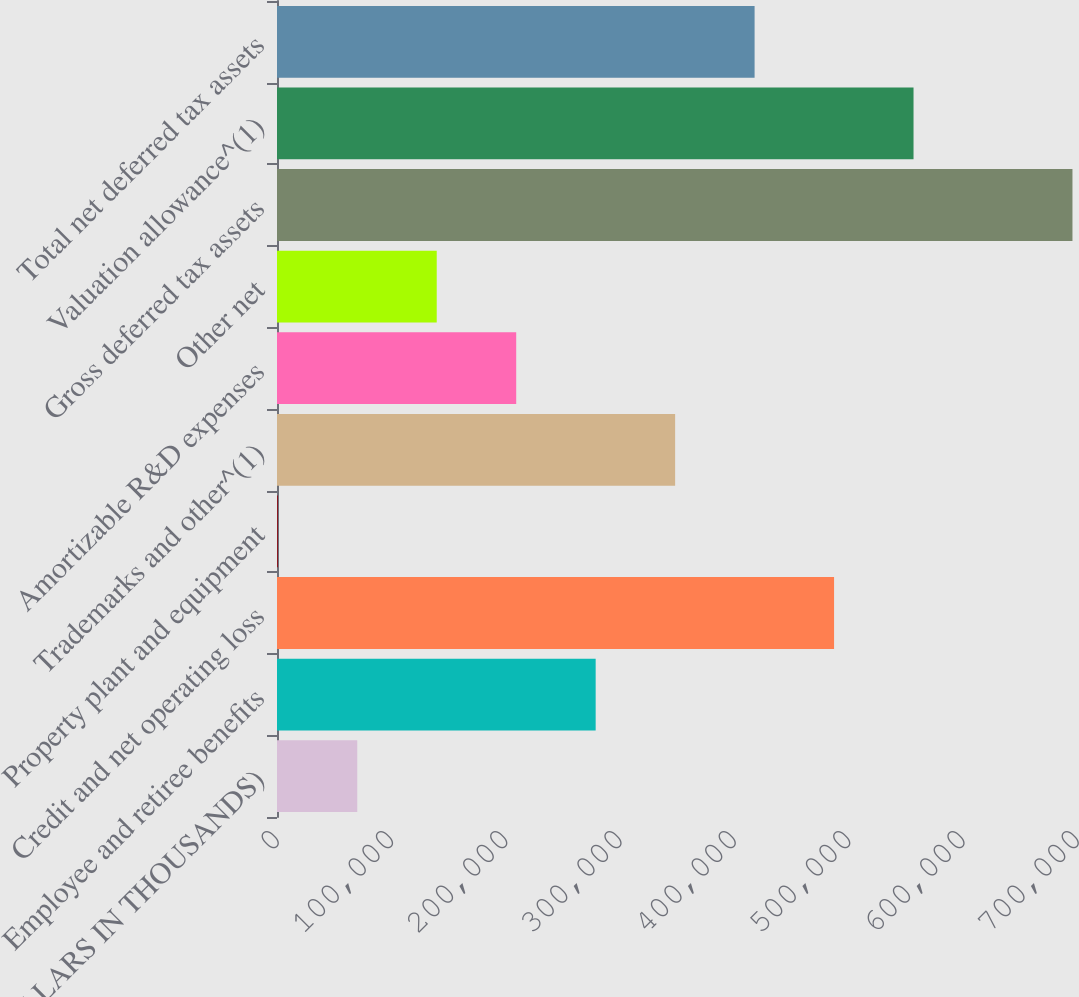<chart> <loc_0><loc_0><loc_500><loc_500><bar_chart><fcel>(DOLLARS IN THOUSANDS)<fcel>Employee and retiree benefits<fcel>Credit and net operating loss<fcel>Property plant and equipment<fcel>Trademarks and other^(1)<fcel>Amortizable R&D expenses<fcel>Other net<fcel>Gross deferred tax assets<fcel>Valuation allowance^(1)<fcel>Total net deferred tax assets<nl><fcel>70232<fcel>278831<fcel>487430<fcel>699<fcel>348364<fcel>209298<fcel>139765<fcel>696029<fcel>556963<fcel>417897<nl></chart> 